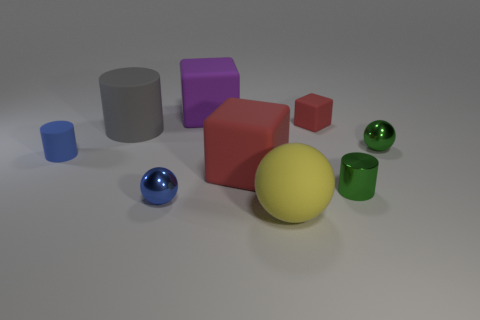There is another blue cylinder that is the same size as the metallic cylinder; what is its material?
Offer a very short reply. Rubber. How many rubber things are right of the block behind the tiny rubber cube?
Your answer should be very brief. 3. There is a small ball on the left side of the metallic cylinder; are there any big things on the left side of it?
Your response must be concise. Yes. Are there any red rubber blocks left of the green sphere?
Provide a short and direct response. Yes. Do the red object that is behind the big red matte object and the purple object have the same shape?
Provide a short and direct response. Yes. How many tiny cyan rubber things have the same shape as the blue matte object?
Provide a short and direct response. 0. Are there any tiny red blocks made of the same material as the yellow object?
Make the answer very short. Yes. What is the material of the red thing that is behind the tiny matte object that is in front of the green ball?
Your response must be concise. Rubber. There is a green shiny sphere that is behind the blue shiny object; what is its size?
Give a very brief answer. Small. Is the color of the small matte cylinder the same as the metal ball that is left of the yellow rubber object?
Offer a very short reply. Yes. 